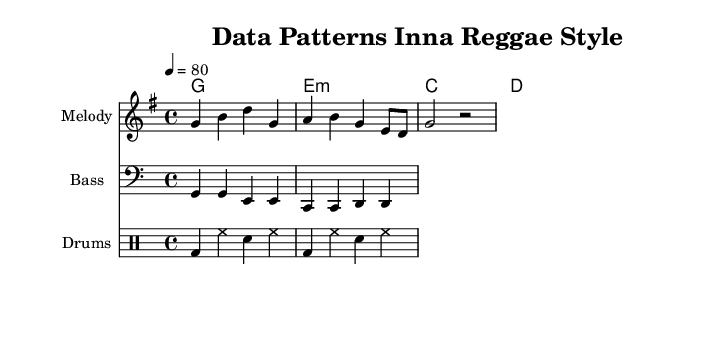What is the key signature of this music? The key signature is G major, which has one sharp (F#). We can determine this by looking at the global section of the code, where it specifies `\key g \major`.
Answer: G major What is the time signature of this music? The time signature is 4/4, meaning there are four beats in each measure. This can be found in the global section of the code with `\time 4/4`.
Answer: 4/4 What is the tempo marking of this music? The tempo marking indicates a speed of 80 beats per minute (BPM), which is shown as `\tempo 4 = 80` in the global section.
Answer: 80 What is the primary theme of the lyrics? The primary theme of the lyrics is data analysis, as noted in the line "An -- a -- ly -- zing da -- ta, yeah we do it right." The lyrics explicitly mention analyzing data, which reflects the focus of the song.
Answer: Data analysis What rhythm pattern does the drum part follow? The drum part follows a typical reggae pattern consisting of bass drums and snare hits laid out in a groove that includes two measures of alternating beats: bass drum (bd), hi-hat (hh), and snare (sn). This can be seen in the drum section with the repetition of notes.
Answer: Bass drum and snare 